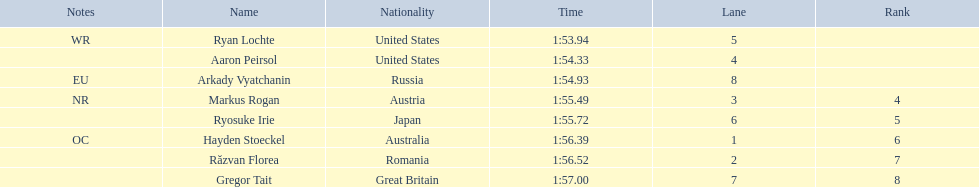How many swimmers finished in less than 1:55? 3. 